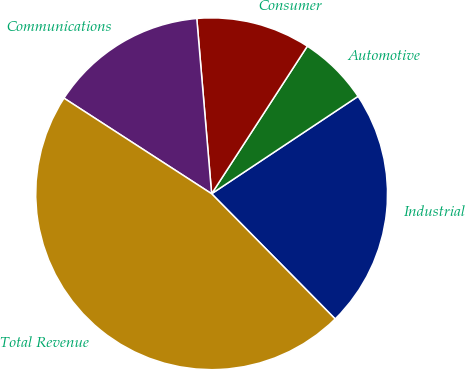Convert chart. <chart><loc_0><loc_0><loc_500><loc_500><pie_chart><fcel>Industrial<fcel>Automotive<fcel>Consumer<fcel>Communications<fcel>Total Revenue<nl><fcel>21.95%<fcel>6.5%<fcel>10.5%<fcel>14.51%<fcel>46.54%<nl></chart> 